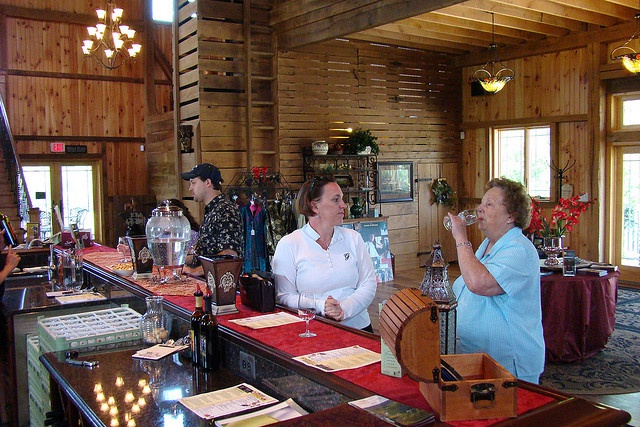Describe the objects in this image and their specific colors. I can see people in brown, lightblue, gray, and black tones, dining table in brown, maroon, black, and lightgray tones, people in brown, lavender, and darkgray tones, dining table in brown, black, maroon, purple, and gray tones, and people in brown, black, gray, and darkgray tones in this image. 